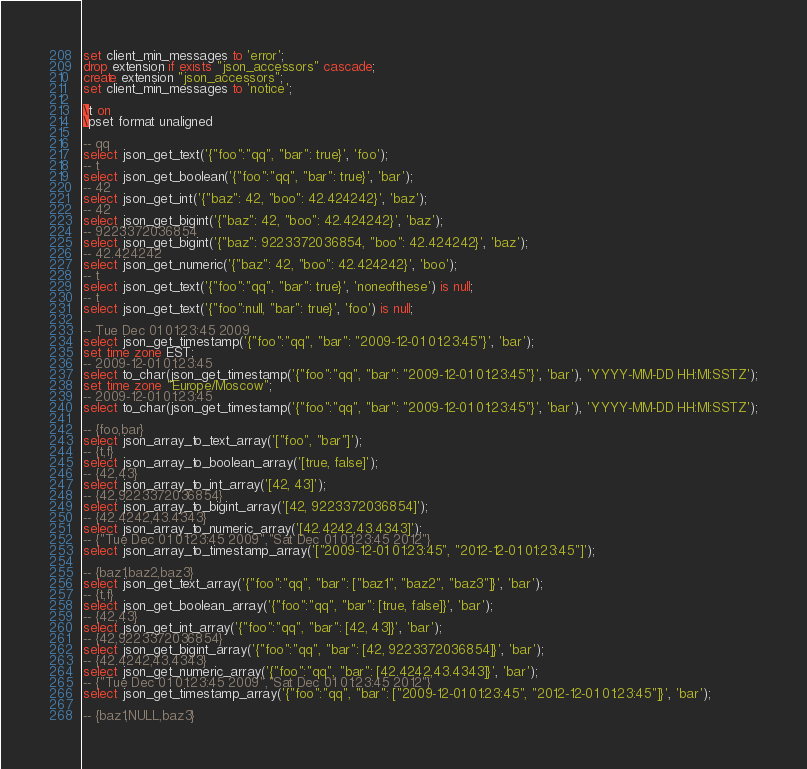<code> <loc_0><loc_0><loc_500><loc_500><_SQL_>set client_min_messages to 'error';
drop extension if exists "json_accessors" cascade;
create extension "json_accessors";
set client_min_messages to 'notice';

\t on
\pset format unaligned

-- qq
select json_get_text('{"foo":"qq", "bar": true}', 'foo');
-- t
select json_get_boolean('{"foo":"qq", "bar": true}', 'bar');
-- 42
select json_get_int('{"baz": 42, "boo": 42.424242}', 'baz');
-- 42
select json_get_bigint('{"baz": 42, "boo": 42.424242}', 'baz');
-- 9223372036854
select json_get_bigint('{"baz": 9223372036854, "boo": 42.424242}', 'baz');
-- 42.424242
select json_get_numeric('{"baz": 42, "boo": 42.424242}', 'boo');
-- t
select json_get_text('{"foo":"qq", "bar": true}', 'noneofthese') is null;
-- t
select json_get_text('{"foo":null, "bar": true}', 'foo') is null;

-- Tue Dec 01 01:23:45 2009
select json_get_timestamp('{"foo":"qq", "bar": "2009-12-01 01:23:45"}', 'bar');
set time zone EST;
-- 2009-12-01 01:23:45
select to_char(json_get_timestamp('{"foo":"qq", "bar": "2009-12-01 01:23:45"}', 'bar'), 'YYYY-MM-DD HH:MI:SSTZ');
set time zone "Europe/Moscow";
-- 2009-12-01 01:23:45
select to_char(json_get_timestamp('{"foo":"qq", "bar": "2009-12-01 01:23:45"}', 'bar'), 'YYYY-MM-DD HH:MI:SSTZ');

-- {foo,bar}
select json_array_to_text_array('["foo", "bar"]');
-- {t,f}
select json_array_to_boolean_array('[true, false]');
-- {42,43}
select json_array_to_int_array('[42, 43]');
-- {42,9223372036854}
select json_array_to_bigint_array('[42, 9223372036854]');
-- {42.4242,43.4343}
select json_array_to_numeric_array('[42.4242,43.4343]');
-- {"Tue Dec 01 01:23:45 2009","Sat Dec 01 01:23:45 2012"}
select json_array_to_timestamp_array('["2009-12-01 01:23:45", "2012-12-01 01:23:45"]');

-- {baz1,baz2,baz3}
select json_get_text_array('{"foo":"qq", "bar": ["baz1", "baz2", "baz3"]}', 'bar');
-- {t,f}
select json_get_boolean_array('{"foo":"qq", "bar": [true, false]}', 'bar');
-- {42,43}
select json_get_int_array('{"foo":"qq", "bar": [42, 43]}', 'bar');
-- {42,9223372036854}
select json_get_bigint_array('{"foo":"qq", "bar": [42, 9223372036854]}', 'bar');
-- {42.4242,43.4343}
select json_get_numeric_array('{"foo":"qq", "bar": [42.4242,43.4343]}', 'bar');
-- {"Tue Dec 01 01:23:45 2009","Sat Dec 01 01:23:45 2012"}
select json_get_timestamp_array('{"foo":"qq", "bar": ["2009-12-01 01:23:45", "2012-12-01 01:23:45"]}', 'bar');

-- {baz1,NULL,baz3}</code> 